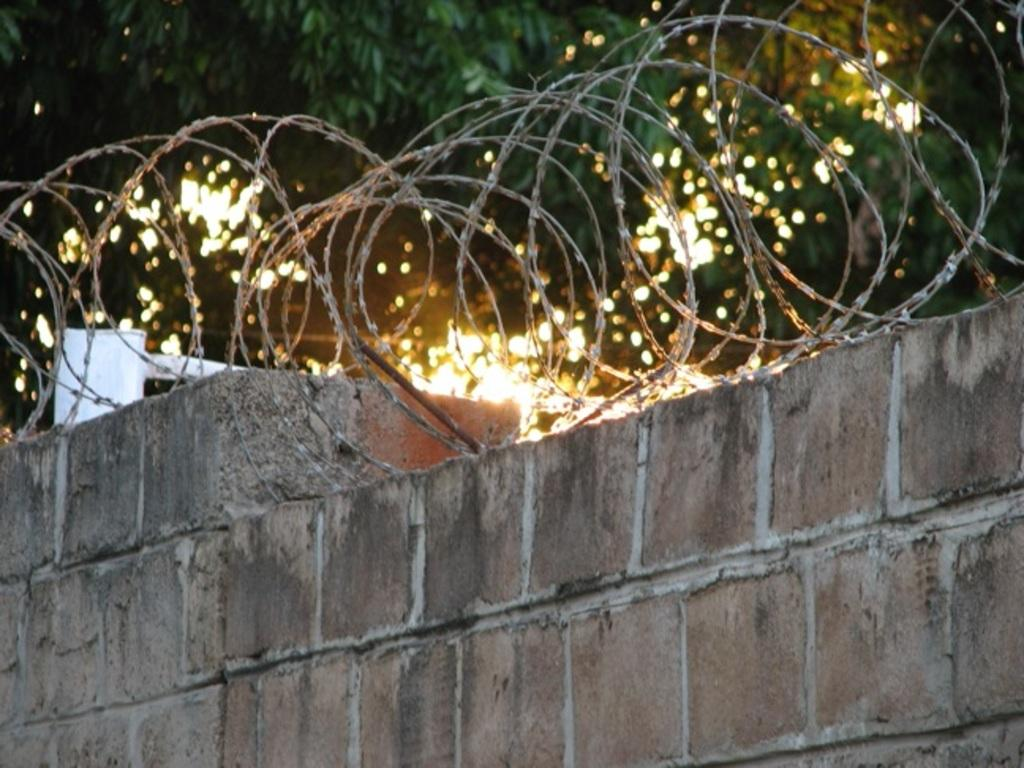What type of wall is present in the image? There is a brick wall in the image. What is attached to the top of the brick wall? There is a metal fence at the top of the brick wall. What can be seen behind the wall? Trees are visible behind the wall. What type of humor can be seen in the image? There is no humor present in the image; it features a brick wall with a metal fence and trees in the background. 